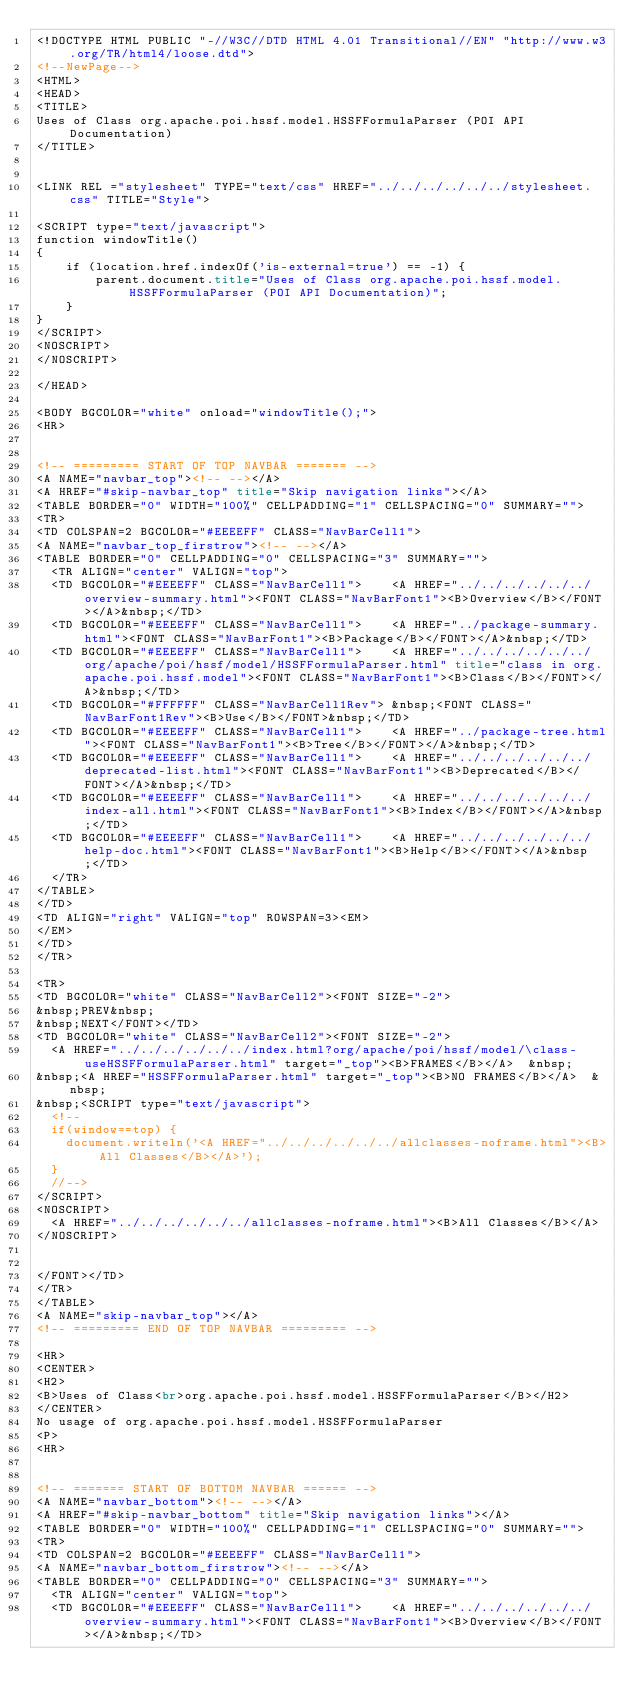<code> <loc_0><loc_0><loc_500><loc_500><_HTML_><!DOCTYPE HTML PUBLIC "-//W3C//DTD HTML 4.01 Transitional//EN" "http://www.w3.org/TR/html4/loose.dtd">
<!--NewPage-->
<HTML>
<HEAD>
<TITLE>
Uses of Class org.apache.poi.hssf.model.HSSFFormulaParser (POI API Documentation)
</TITLE>


<LINK REL ="stylesheet" TYPE="text/css" HREF="../../../../../../stylesheet.css" TITLE="Style">

<SCRIPT type="text/javascript">
function windowTitle()
{
    if (location.href.indexOf('is-external=true') == -1) {
        parent.document.title="Uses of Class org.apache.poi.hssf.model.HSSFFormulaParser (POI API Documentation)";
    }
}
</SCRIPT>
<NOSCRIPT>
</NOSCRIPT>

</HEAD>

<BODY BGCOLOR="white" onload="windowTitle();">
<HR>


<!-- ========= START OF TOP NAVBAR ======= -->
<A NAME="navbar_top"><!-- --></A>
<A HREF="#skip-navbar_top" title="Skip navigation links"></A>
<TABLE BORDER="0" WIDTH="100%" CELLPADDING="1" CELLSPACING="0" SUMMARY="">
<TR>
<TD COLSPAN=2 BGCOLOR="#EEEEFF" CLASS="NavBarCell1">
<A NAME="navbar_top_firstrow"><!-- --></A>
<TABLE BORDER="0" CELLPADDING="0" CELLSPACING="3" SUMMARY="">
  <TR ALIGN="center" VALIGN="top">
  <TD BGCOLOR="#EEEEFF" CLASS="NavBarCell1">    <A HREF="../../../../../../overview-summary.html"><FONT CLASS="NavBarFont1"><B>Overview</B></FONT></A>&nbsp;</TD>
  <TD BGCOLOR="#EEEEFF" CLASS="NavBarCell1">    <A HREF="../package-summary.html"><FONT CLASS="NavBarFont1"><B>Package</B></FONT></A>&nbsp;</TD>
  <TD BGCOLOR="#EEEEFF" CLASS="NavBarCell1">    <A HREF="../../../../../../org/apache/poi/hssf/model/HSSFFormulaParser.html" title="class in org.apache.poi.hssf.model"><FONT CLASS="NavBarFont1"><B>Class</B></FONT></A>&nbsp;</TD>
  <TD BGCOLOR="#FFFFFF" CLASS="NavBarCell1Rev"> &nbsp;<FONT CLASS="NavBarFont1Rev"><B>Use</B></FONT>&nbsp;</TD>
  <TD BGCOLOR="#EEEEFF" CLASS="NavBarCell1">    <A HREF="../package-tree.html"><FONT CLASS="NavBarFont1"><B>Tree</B></FONT></A>&nbsp;</TD>
  <TD BGCOLOR="#EEEEFF" CLASS="NavBarCell1">    <A HREF="../../../../../../deprecated-list.html"><FONT CLASS="NavBarFont1"><B>Deprecated</B></FONT></A>&nbsp;</TD>
  <TD BGCOLOR="#EEEEFF" CLASS="NavBarCell1">    <A HREF="../../../../../../index-all.html"><FONT CLASS="NavBarFont1"><B>Index</B></FONT></A>&nbsp;</TD>
  <TD BGCOLOR="#EEEEFF" CLASS="NavBarCell1">    <A HREF="../../../../../../help-doc.html"><FONT CLASS="NavBarFont1"><B>Help</B></FONT></A>&nbsp;</TD>
  </TR>
</TABLE>
</TD>
<TD ALIGN="right" VALIGN="top" ROWSPAN=3><EM>
</EM>
</TD>
</TR>

<TR>
<TD BGCOLOR="white" CLASS="NavBarCell2"><FONT SIZE="-2">
&nbsp;PREV&nbsp;
&nbsp;NEXT</FONT></TD>
<TD BGCOLOR="white" CLASS="NavBarCell2"><FONT SIZE="-2">
  <A HREF="../../../../../../index.html?org/apache/poi/hssf/model/\class-useHSSFFormulaParser.html" target="_top"><B>FRAMES</B></A>  &nbsp;
&nbsp;<A HREF="HSSFFormulaParser.html" target="_top"><B>NO FRAMES</B></A>  &nbsp;
&nbsp;<SCRIPT type="text/javascript">
  <!--
  if(window==top) {
    document.writeln('<A HREF="../../../../../../allclasses-noframe.html"><B>All Classes</B></A>');
  }
  //-->
</SCRIPT>
<NOSCRIPT>
  <A HREF="../../../../../../allclasses-noframe.html"><B>All Classes</B></A>
</NOSCRIPT>


</FONT></TD>
</TR>
</TABLE>
<A NAME="skip-navbar_top"></A>
<!-- ========= END OF TOP NAVBAR ========= -->

<HR>
<CENTER>
<H2>
<B>Uses of Class<br>org.apache.poi.hssf.model.HSSFFormulaParser</B></H2>
</CENTER>
No usage of org.apache.poi.hssf.model.HSSFFormulaParser
<P>
<HR>


<!-- ======= START OF BOTTOM NAVBAR ====== -->
<A NAME="navbar_bottom"><!-- --></A>
<A HREF="#skip-navbar_bottom" title="Skip navigation links"></A>
<TABLE BORDER="0" WIDTH="100%" CELLPADDING="1" CELLSPACING="0" SUMMARY="">
<TR>
<TD COLSPAN=2 BGCOLOR="#EEEEFF" CLASS="NavBarCell1">
<A NAME="navbar_bottom_firstrow"><!-- --></A>
<TABLE BORDER="0" CELLPADDING="0" CELLSPACING="3" SUMMARY="">
  <TR ALIGN="center" VALIGN="top">
  <TD BGCOLOR="#EEEEFF" CLASS="NavBarCell1">    <A HREF="../../../../../../overview-summary.html"><FONT CLASS="NavBarFont1"><B>Overview</B></FONT></A>&nbsp;</TD></code> 